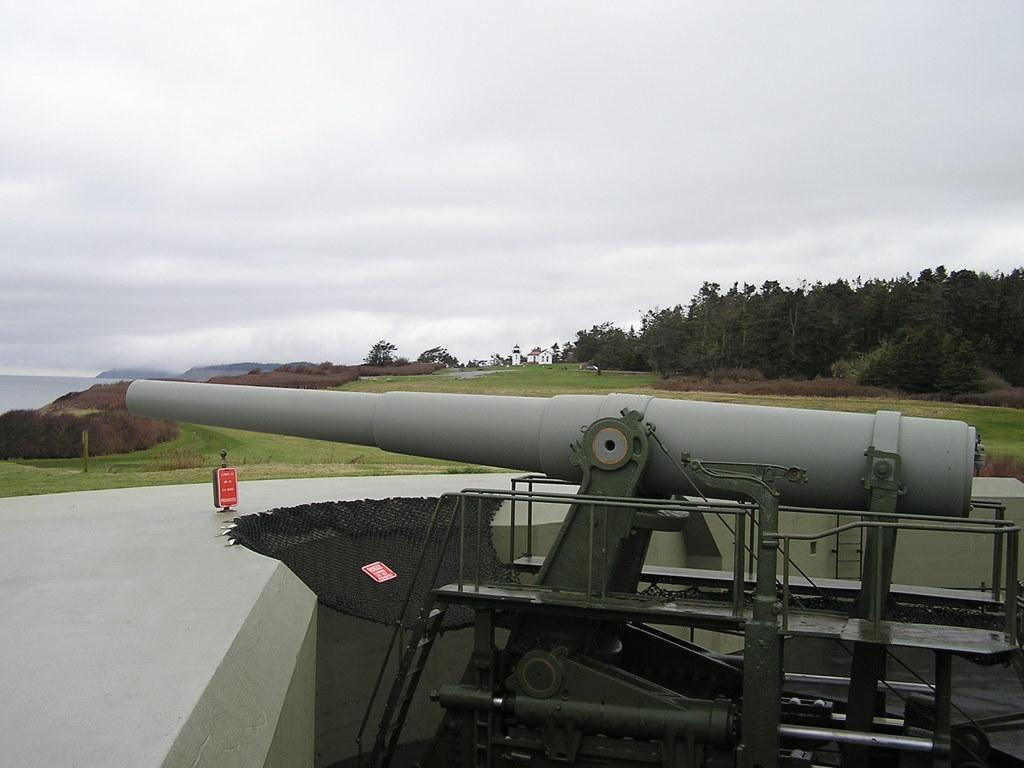What is the main object in the image? There is a canon in the image. What is located to the left of the canon? There is a board to the left of the canon. What can be seen in the background of the image? The ground, many trees, and the sky are visible in the background of the image. Where is the tray placed in the image? There is no tray present in the image. What action is the bedroom performing in the image? There is no bedroom present in the image, and therefore no action can be attributed to it. 